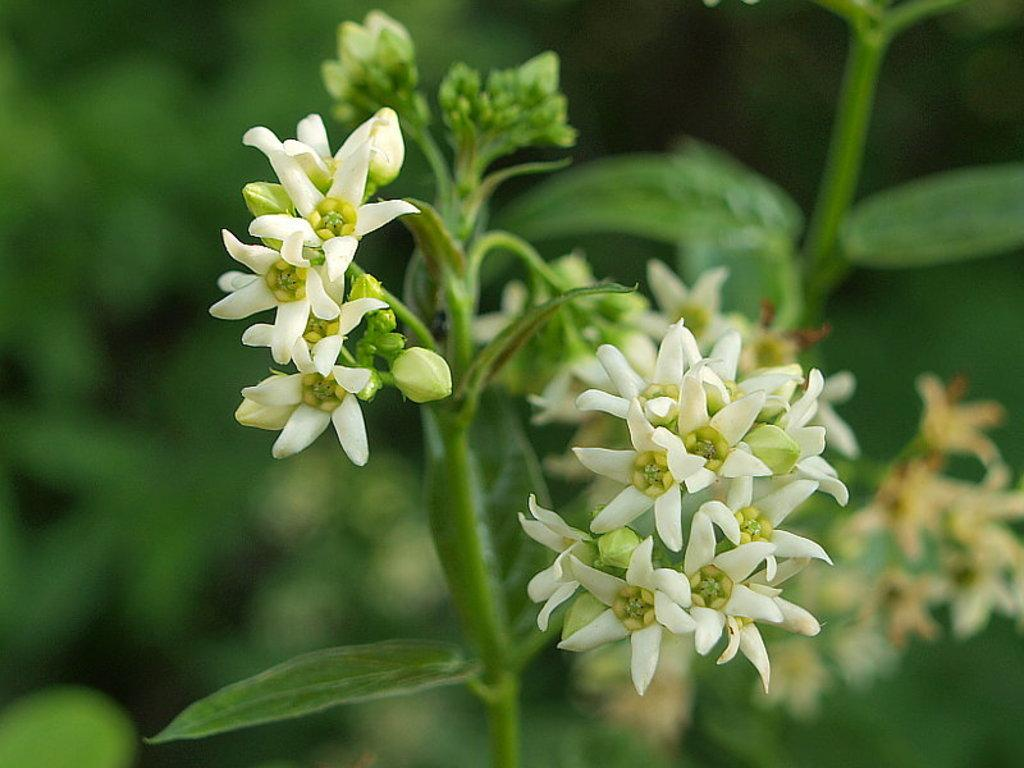What is the main subject of the image? There is a plant with flowers in the center of the image. Can you describe the background of the image? The background of the image is blurred. What type of kite is being flown by the person in the image? There is no person or kite present in the image; it features a plant with flowers and a blurred background. 